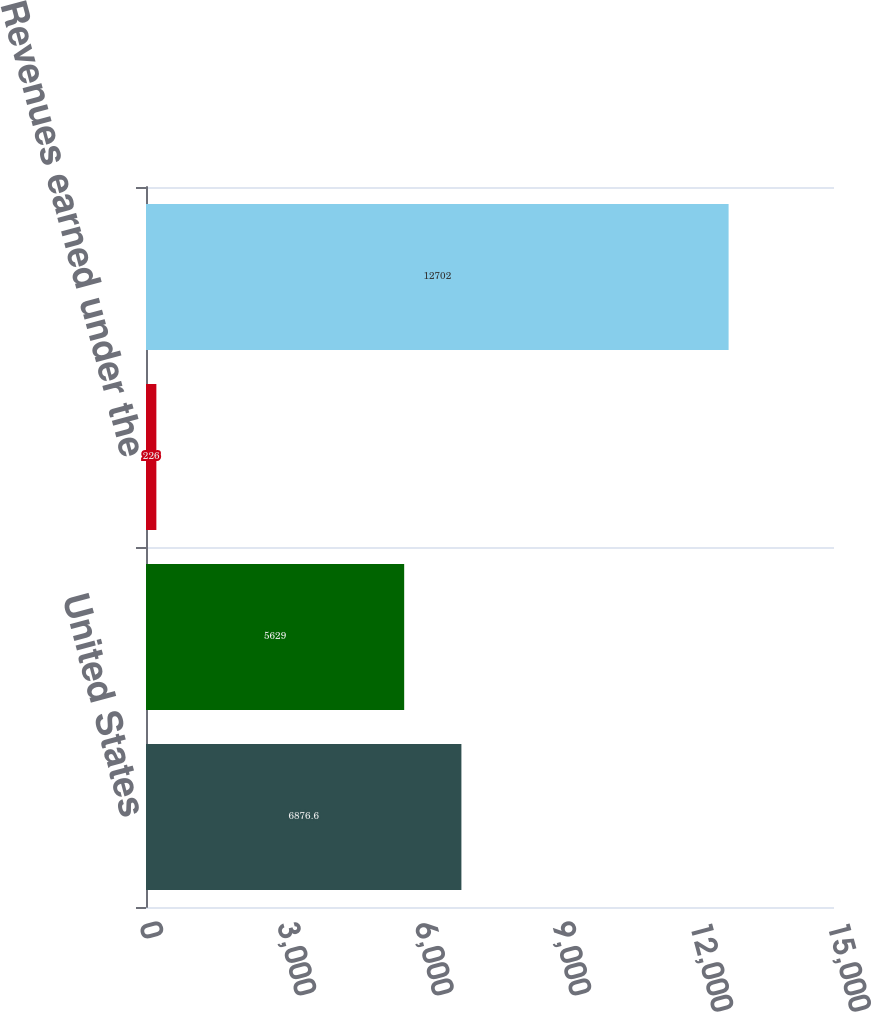<chart> <loc_0><loc_0><loc_500><loc_500><bar_chart><fcel>United States<fcel>International<fcel>Revenues earned under the<fcel>Net operating revenues<nl><fcel>6876.6<fcel>5629<fcel>226<fcel>12702<nl></chart> 